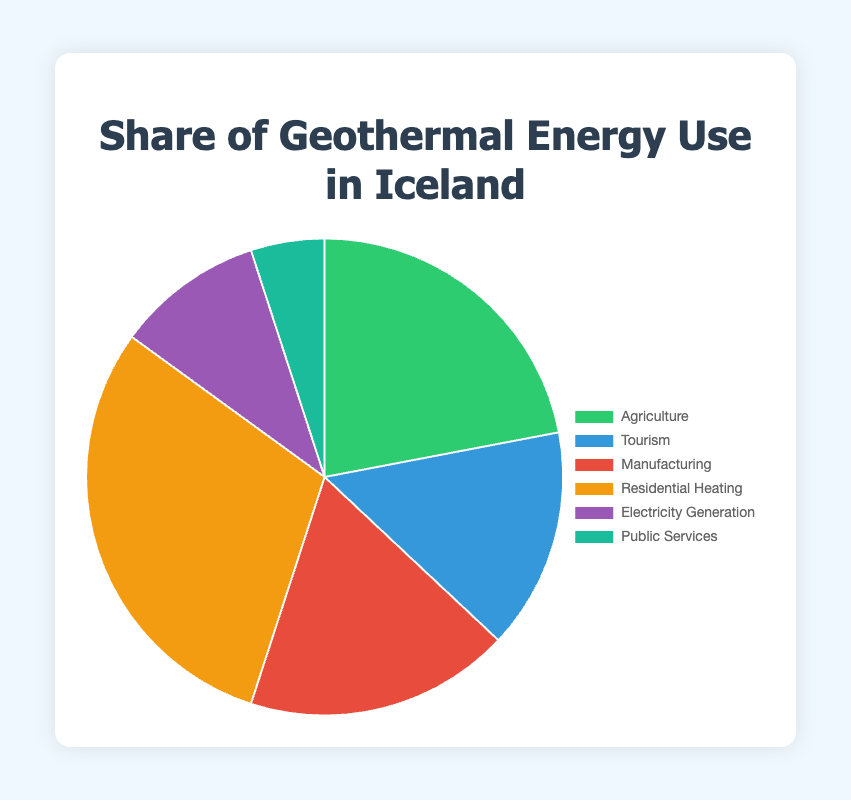Which industry uses the highest percentage of geothermal energy? The largest slice in the pie chart corresponds to the sector 'Residential Heating'. The data shows that this industry uses 30% of the geothermal energy.
Answer: Residential Heating Which sector uses more geothermal energy: Agriculture or Manufacturing? Comparing the pie slices, Agriculture is marked with 22% and Manufacturing with 18%. Hence, Agriculture uses more geothermal energy than Manufacturing.
Answer: Agriculture What is the combined share of geothermal energy use for Agriculture and Tourism? Adding the percentages for Agriculture (22%) and Tourism (15%) gives a total combined share of 37%.
Answer: 37% If we combine the share percentages of Electricity Generation and Public Services, how does it compare to the share of Manufacturing? Electricity Generation (10%) plus Public Services (5%) equals 15%, which is less than the share of Manufacturing (18%).
Answer: Less than Manufacturing What is the percentage difference between the largest and smallest users of geothermal energy? The largest user is Residential Heating at 30% and the smallest is Public Services at 5%. The difference is 30% - 5% = 25%.
Answer: 25% How many industries listed use less than 20% of the geothermal energy? Comparing the slices, Tourism (15%), Electricity Generation (10%), and Public Services (5%) each use less than 20% of geothermal energy. There are three industries in total.
Answer: 3 What percentage of geothermal energy is used by industries other than Residential Heating? Subtracting Residential Heating's share (30%) from 100% gives 100% - 30% = 70%.
Answer: 70% What industries share the same color or similar shades in the pie chart? By examining the pie chart visually, Agriculture (green) and Public Services (turquoise) look similar in shade though distinct, while Tourism (blue) and Manufacturing (red) have different, distinguishable colors.
Answer: None, they all have different shades Which industry slice is slightly larger in size: Manufacturing or Electricity Generation? Visually comparing the pie slices, Manufacturing (18%) is larger than Electricity Generation (10%).
Answer: Manufacturing What is the share of geothermal energy used by Greenhouse Farming and Fish Farming combined if Greenhouse Farming uses 60% of Agriculture’s share, and Fish Farming uses the rest? Agriculture uses 22% of geothermal energy. Greenhouse Farming uses 60% of 22%, which is 0.60 * 22 = 13.2%, and Fish Farming uses the remaining 40%, which is 0.40 * 22 = 8.8%. Combining these gives 13.2% + 8.8% = 22%.
Answer: 22% 